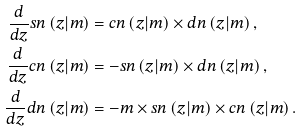Convert formula to latex. <formula><loc_0><loc_0><loc_500><loc_500>\frac { d } { d z } s n \left ( z | m \right ) & = c n \left ( z | m \right ) \times d n \left ( z | m \right ) , \\ \frac { d } { d z } c n \left ( z | m \right ) & = - s n \left ( z | m \right ) \times d n \left ( z | m \right ) , \\ \frac { d } { d z } d n \left ( z | m \right ) & = - m \times s n \left ( z | m \right ) \times c n \left ( z | m \right ) .</formula> 